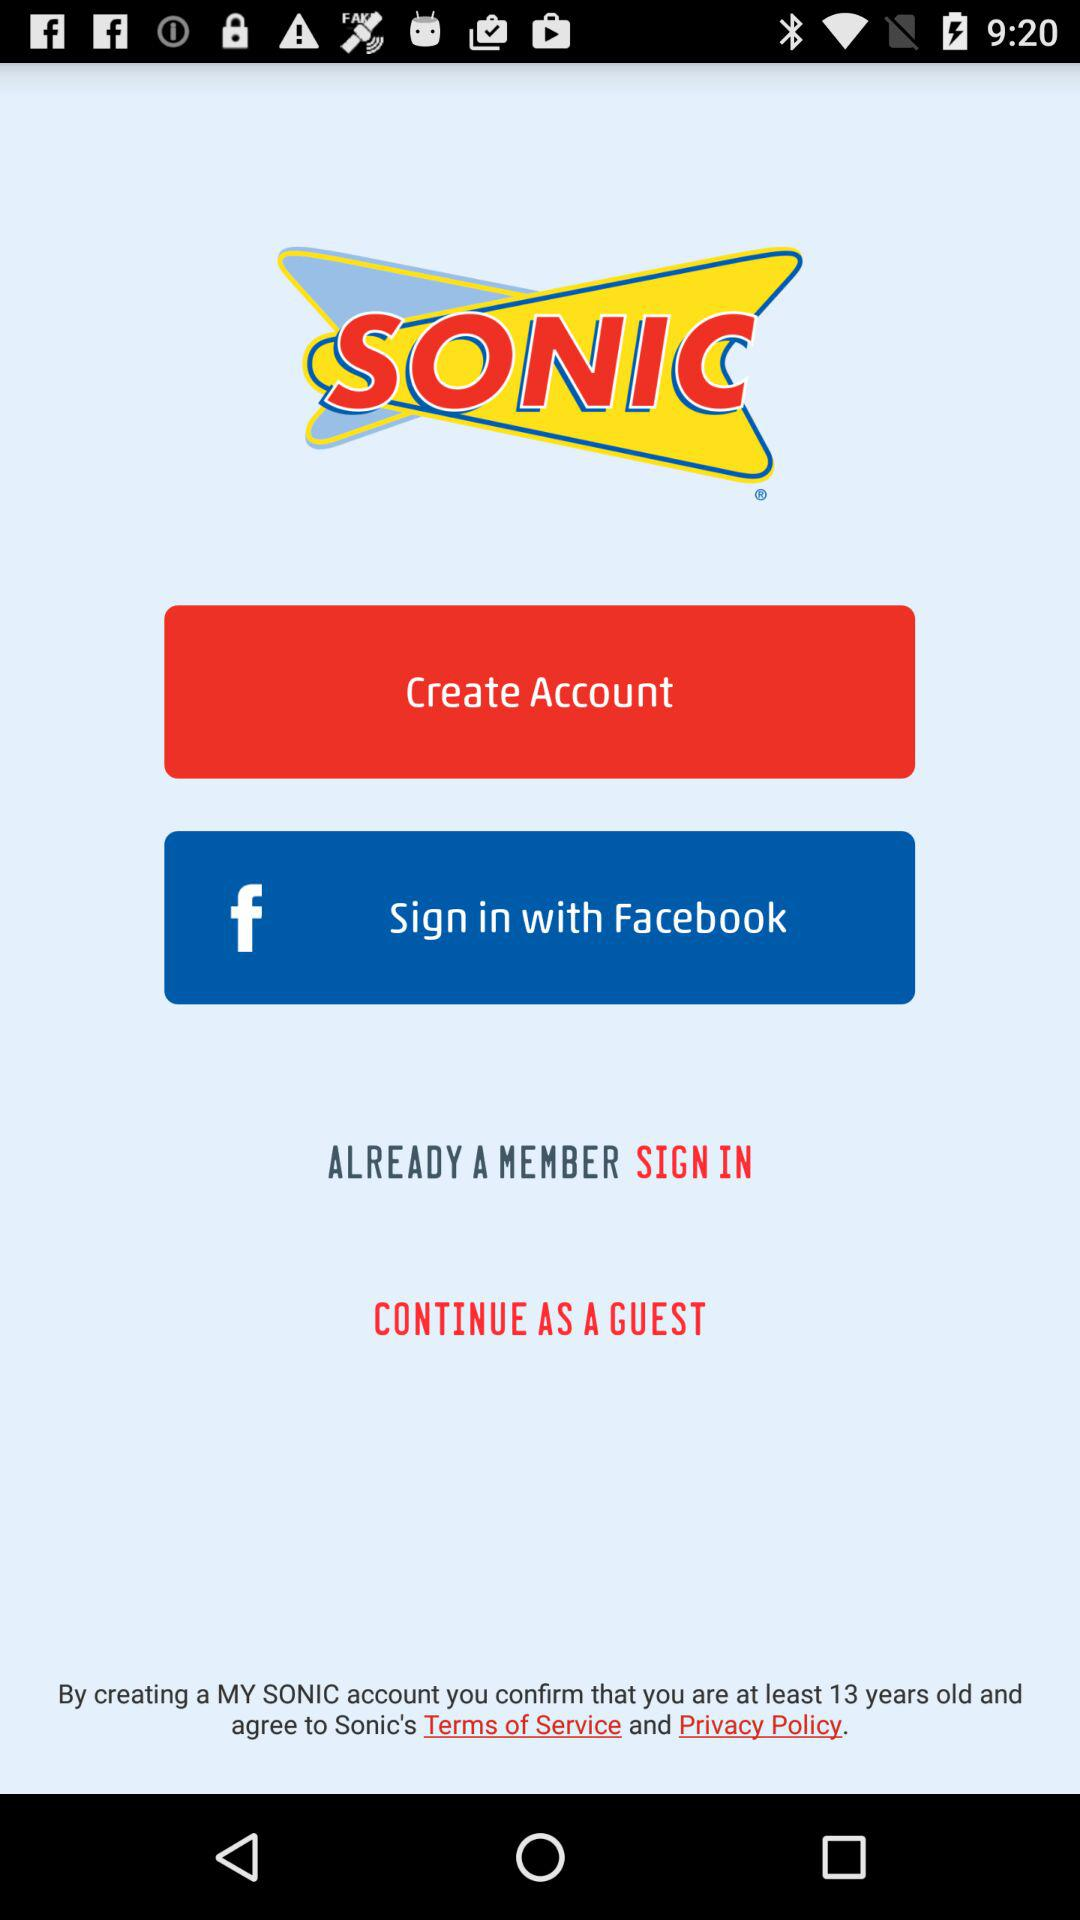What is the name of the application? The name of the application is "SONIC". 